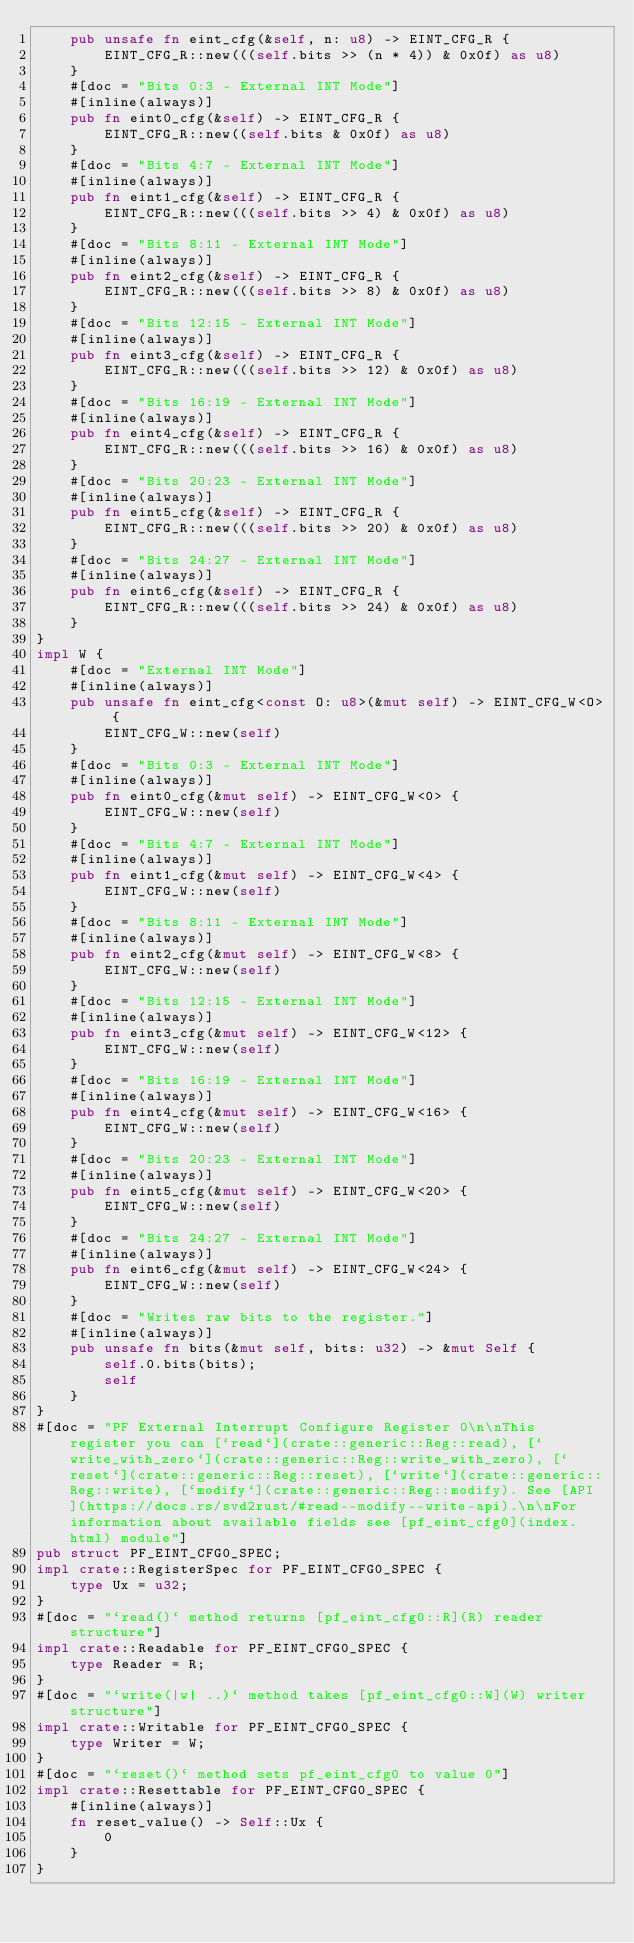<code> <loc_0><loc_0><loc_500><loc_500><_Rust_>    pub unsafe fn eint_cfg(&self, n: u8) -> EINT_CFG_R {
        EINT_CFG_R::new(((self.bits >> (n * 4)) & 0x0f) as u8)
    }
    #[doc = "Bits 0:3 - External INT Mode"]
    #[inline(always)]
    pub fn eint0_cfg(&self) -> EINT_CFG_R {
        EINT_CFG_R::new((self.bits & 0x0f) as u8)
    }
    #[doc = "Bits 4:7 - External INT Mode"]
    #[inline(always)]
    pub fn eint1_cfg(&self) -> EINT_CFG_R {
        EINT_CFG_R::new(((self.bits >> 4) & 0x0f) as u8)
    }
    #[doc = "Bits 8:11 - External INT Mode"]
    #[inline(always)]
    pub fn eint2_cfg(&self) -> EINT_CFG_R {
        EINT_CFG_R::new(((self.bits >> 8) & 0x0f) as u8)
    }
    #[doc = "Bits 12:15 - External INT Mode"]
    #[inline(always)]
    pub fn eint3_cfg(&self) -> EINT_CFG_R {
        EINT_CFG_R::new(((self.bits >> 12) & 0x0f) as u8)
    }
    #[doc = "Bits 16:19 - External INT Mode"]
    #[inline(always)]
    pub fn eint4_cfg(&self) -> EINT_CFG_R {
        EINT_CFG_R::new(((self.bits >> 16) & 0x0f) as u8)
    }
    #[doc = "Bits 20:23 - External INT Mode"]
    #[inline(always)]
    pub fn eint5_cfg(&self) -> EINT_CFG_R {
        EINT_CFG_R::new(((self.bits >> 20) & 0x0f) as u8)
    }
    #[doc = "Bits 24:27 - External INT Mode"]
    #[inline(always)]
    pub fn eint6_cfg(&self) -> EINT_CFG_R {
        EINT_CFG_R::new(((self.bits >> 24) & 0x0f) as u8)
    }
}
impl W {
    #[doc = "External INT Mode"]
    #[inline(always)]
    pub unsafe fn eint_cfg<const O: u8>(&mut self) -> EINT_CFG_W<O> {
        EINT_CFG_W::new(self)
    }
    #[doc = "Bits 0:3 - External INT Mode"]
    #[inline(always)]
    pub fn eint0_cfg(&mut self) -> EINT_CFG_W<0> {
        EINT_CFG_W::new(self)
    }
    #[doc = "Bits 4:7 - External INT Mode"]
    #[inline(always)]
    pub fn eint1_cfg(&mut self) -> EINT_CFG_W<4> {
        EINT_CFG_W::new(self)
    }
    #[doc = "Bits 8:11 - External INT Mode"]
    #[inline(always)]
    pub fn eint2_cfg(&mut self) -> EINT_CFG_W<8> {
        EINT_CFG_W::new(self)
    }
    #[doc = "Bits 12:15 - External INT Mode"]
    #[inline(always)]
    pub fn eint3_cfg(&mut self) -> EINT_CFG_W<12> {
        EINT_CFG_W::new(self)
    }
    #[doc = "Bits 16:19 - External INT Mode"]
    #[inline(always)]
    pub fn eint4_cfg(&mut self) -> EINT_CFG_W<16> {
        EINT_CFG_W::new(self)
    }
    #[doc = "Bits 20:23 - External INT Mode"]
    #[inline(always)]
    pub fn eint5_cfg(&mut self) -> EINT_CFG_W<20> {
        EINT_CFG_W::new(self)
    }
    #[doc = "Bits 24:27 - External INT Mode"]
    #[inline(always)]
    pub fn eint6_cfg(&mut self) -> EINT_CFG_W<24> {
        EINT_CFG_W::new(self)
    }
    #[doc = "Writes raw bits to the register."]
    #[inline(always)]
    pub unsafe fn bits(&mut self, bits: u32) -> &mut Self {
        self.0.bits(bits);
        self
    }
}
#[doc = "PF External Interrupt Configure Register 0\n\nThis register you can [`read`](crate::generic::Reg::read), [`write_with_zero`](crate::generic::Reg::write_with_zero), [`reset`](crate::generic::Reg::reset), [`write`](crate::generic::Reg::write), [`modify`](crate::generic::Reg::modify). See [API](https://docs.rs/svd2rust/#read--modify--write-api).\n\nFor information about available fields see [pf_eint_cfg0](index.html) module"]
pub struct PF_EINT_CFG0_SPEC;
impl crate::RegisterSpec for PF_EINT_CFG0_SPEC {
    type Ux = u32;
}
#[doc = "`read()` method returns [pf_eint_cfg0::R](R) reader structure"]
impl crate::Readable for PF_EINT_CFG0_SPEC {
    type Reader = R;
}
#[doc = "`write(|w| ..)` method takes [pf_eint_cfg0::W](W) writer structure"]
impl crate::Writable for PF_EINT_CFG0_SPEC {
    type Writer = W;
}
#[doc = "`reset()` method sets pf_eint_cfg0 to value 0"]
impl crate::Resettable for PF_EINT_CFG0_SPEC {
    #[inline(always)]
    fn reset_value() -> Self::Ux {
        0
    }
}
</code> 